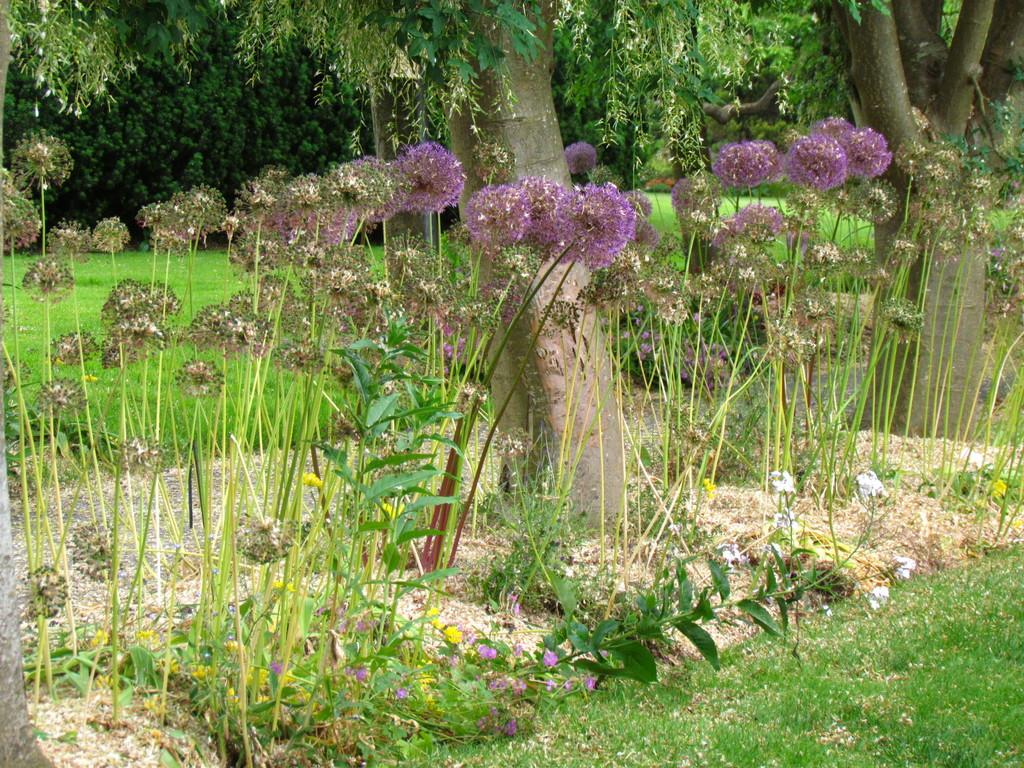What type of plants can be seen in the image? There are flowers in the image. What type of vegetation is present at ground level? There is grass in the image. What can be seen in the distance in the image? There are trees in the background of the image. What type of punishment is being administered to the flowers in the image? There is no punishment being administered to the flowers in the image; they are simply growing and blooming. 